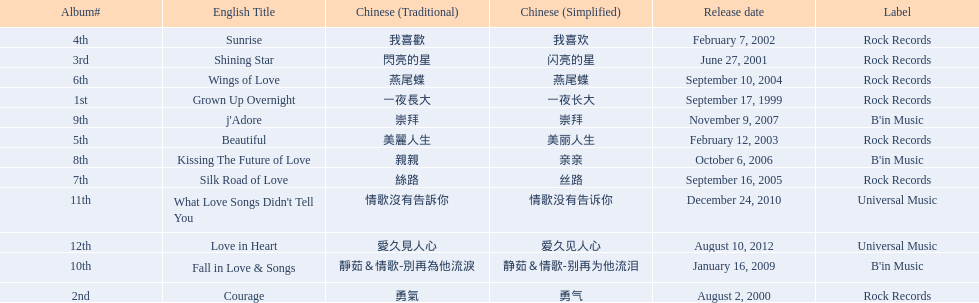Which english titles were released during even years? Courage, Sunrise, Silk Road of Love, Kissing The Future of Love, What Love Songs Didn't Tell You, Love in Heart. Out of the following, which one was released under b's in music? Kissing The Future of Love. 